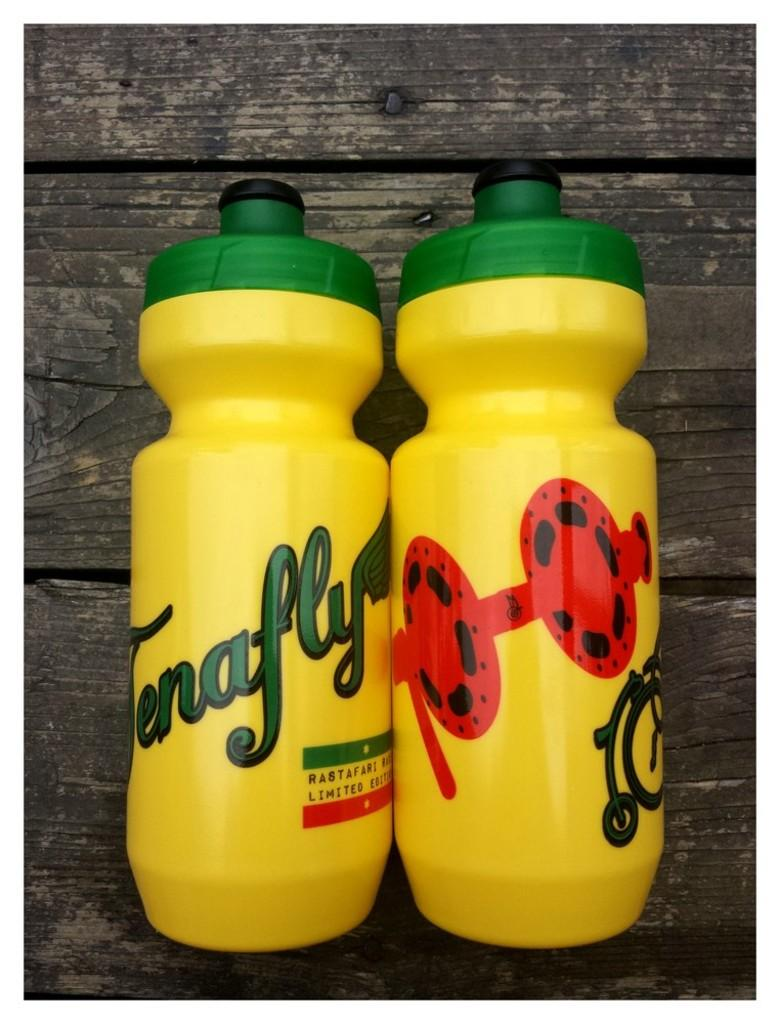<image>
Share a concise interpretation of the image provided. Two yellow water bottles with a green top from Tenafly. 